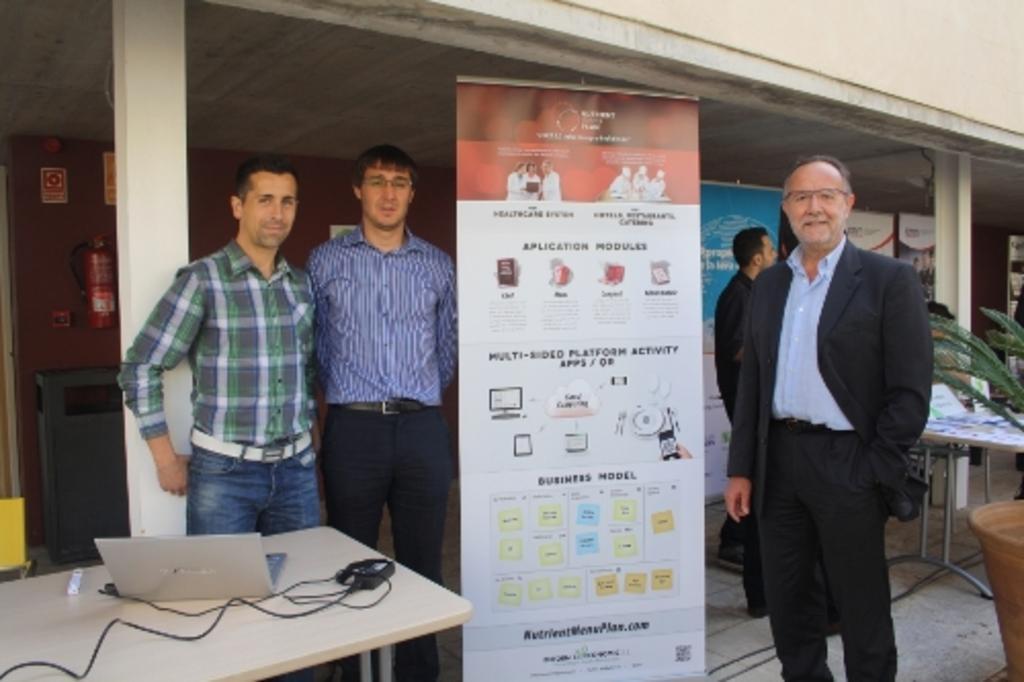Can you describe this image briefly? Here we can see four persons are standing on the floor. This is banner. There is a table. On the table there is a laptop. This is pillar and there is a wall. 